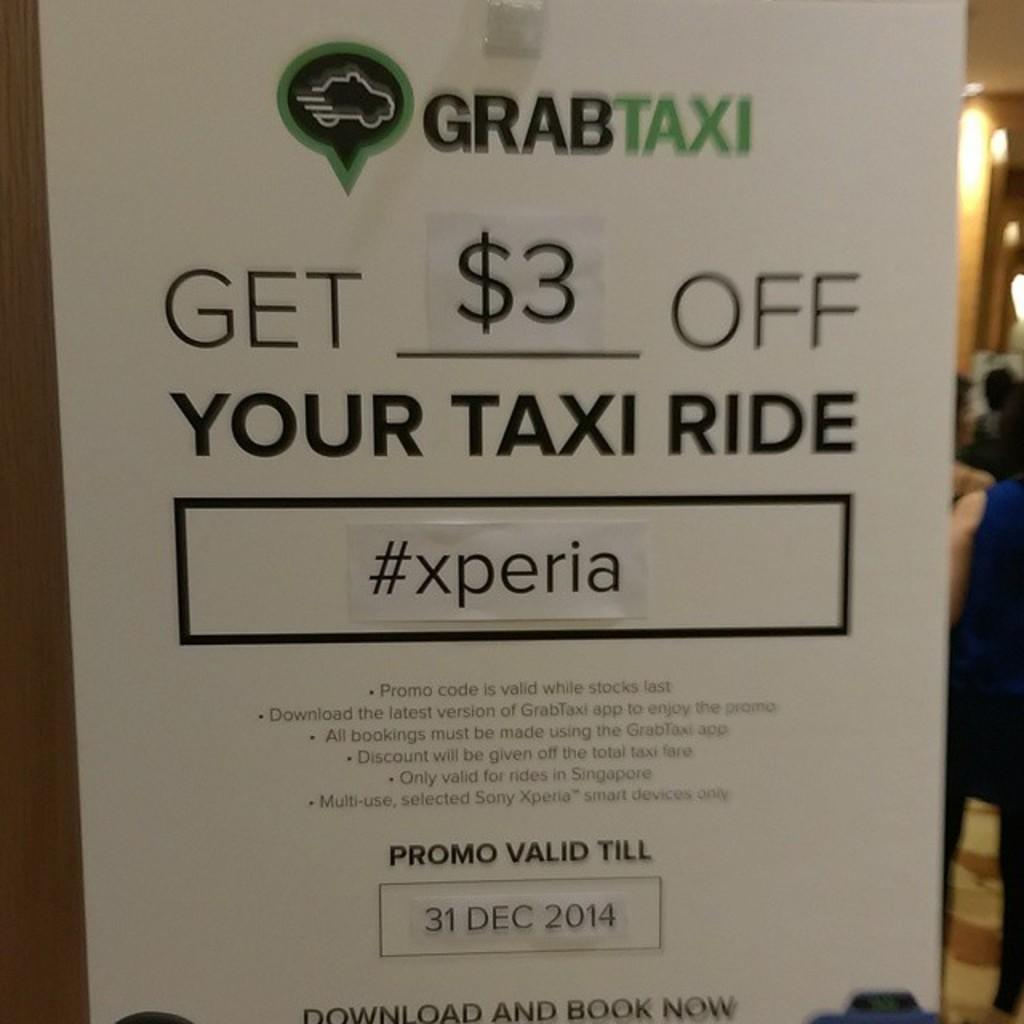<image>
Present a compact description of the photo's key features. an ad for grabtax to get your # off your taxi ride 